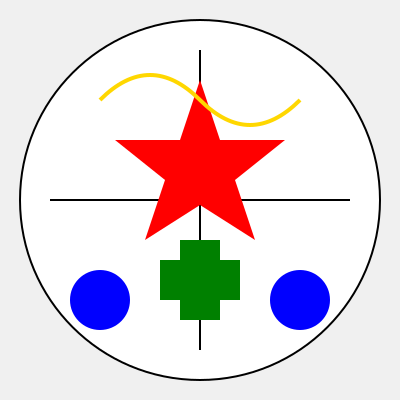In this mixed cultural emblem, identify the number of traditional Jamaican symbols and the number of traditional Canadian symbols represented. To answer this question, we need to analyze the emblem and identify symbols associated with both Jamaica and Canada:

1. Jamaican symbols:
   a. Green cross: Represents the Jamaican flag's cross
   b. Yellow curved line: Symbolizes the Jamaican sun
   c. Two blue circles: Represent the blue mountains of Jamaica
   Total Jamaican symbols: 3

2. Canadian symbols:
   a. Red maple leaf: The central symbol of the Canadian flag
   b. White background with red elements: Reflects the colors of the Canadian flag
   Total Canadian symbols: 2

3. Count:
   Jamaican symbols: 3
   Canadian symbols: 2

Therefore, the emblem contains 3 Jamaican symbols and 2 Canadian symbols.
Answer: 3 Jamaican, 2 Canadian 